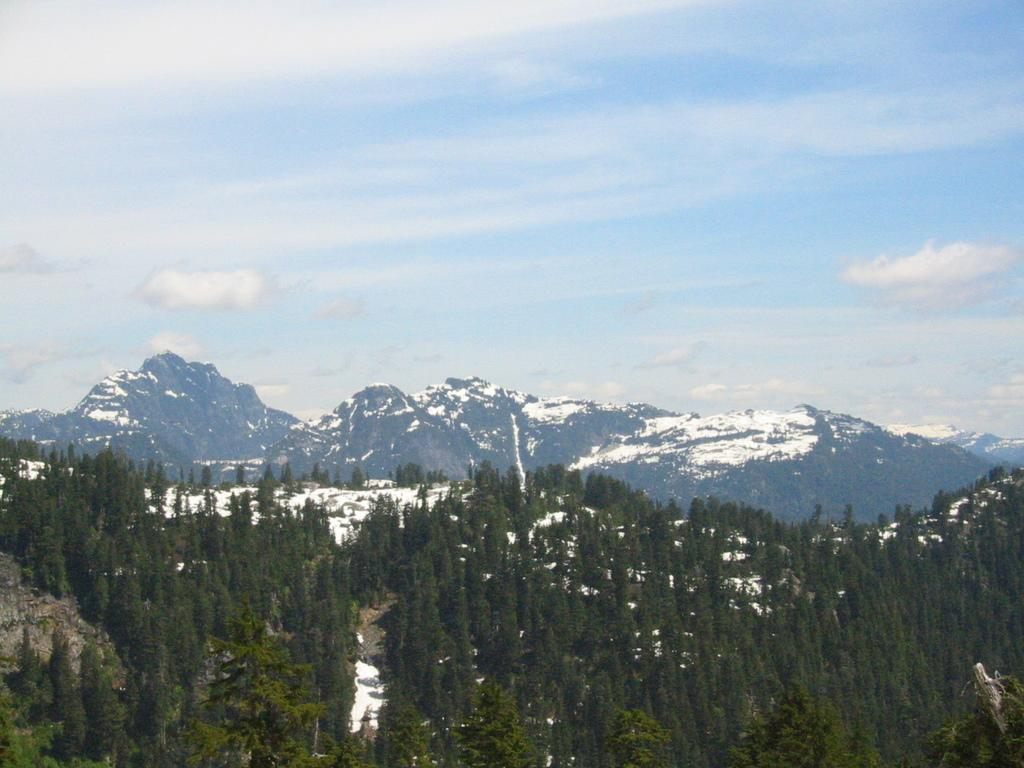What type of vegetation can be seen in the image? There are trees in the image. What is covering the ground in the image? There is snow in the image. What type of geographical feature is visible in the image? There are mountains in the image. What is visible in the sky in the image? The sky is visible in the image. Where might this image have been taken? The image may have been taken near mountains, given their presence in the image. What type of hen can be seen in the image? There is no hen present in the image. What committee is responsible for the maintenance of the mountains in the image? There is no committee mentioned or implied in the image; it is a natural landscape. 